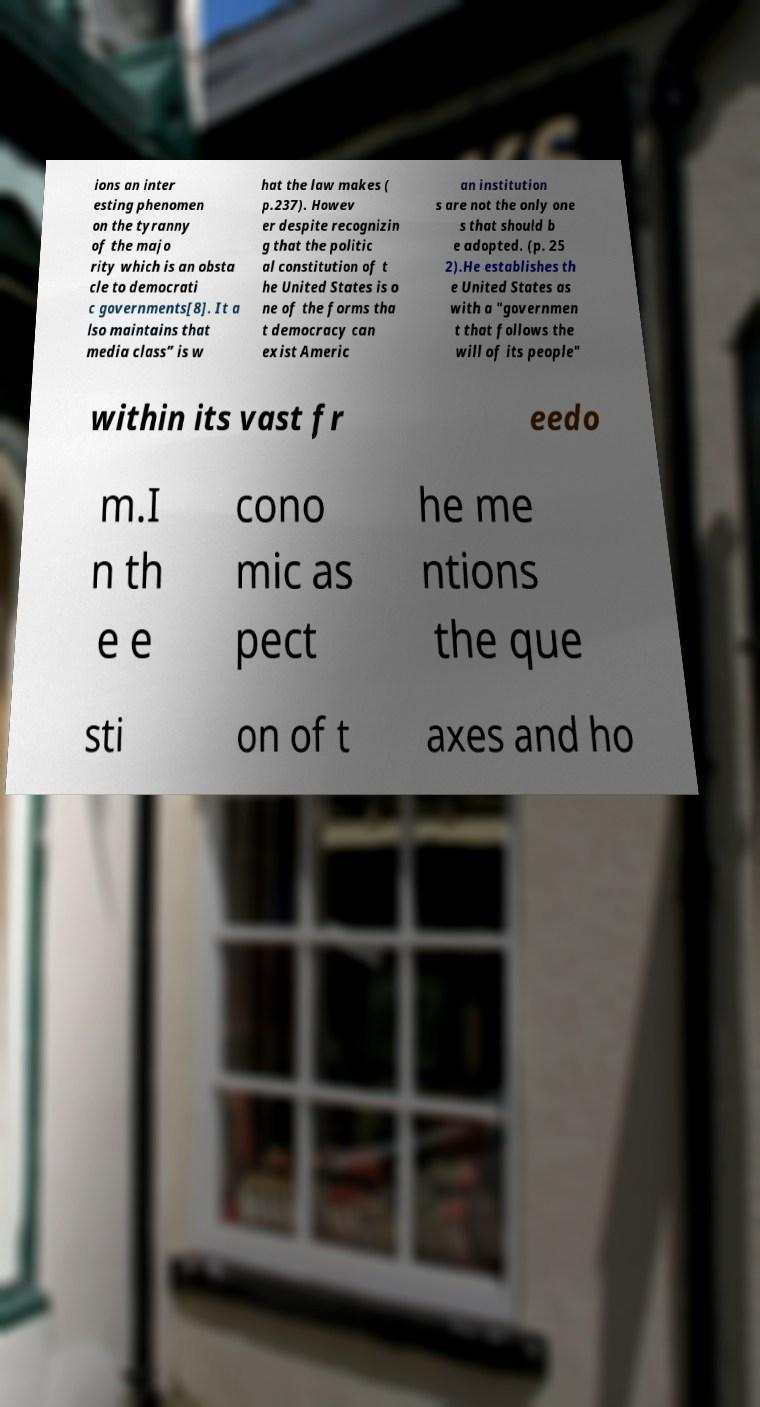Can you read and provide the text displayed in the image?This photo seems to have some interesting text. Can you extract and type it out for me? ions an inter esting phenomen on the tyranny of the majo rity which is an obsta cle to democrati c governments[8]. It a lso maintains that media class” is w hat the law makes ( p.237). Howev er despite recognizin g that the politic al constitution of t he United States is o ne of the forms tha t democracy can exist Americ an institution s are not the only one s that should b e adopted. (p. 25 2).He establishes th e United States as with a "governmen t that follows the will of its people" within its vast fr eedo m.I n th e e cono mic as pect he me ntions the que sti on of t axes and ho 